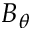<formula> <loc_0><loc_0><loc_500><loc_500>B _ { \theta }</formula> 